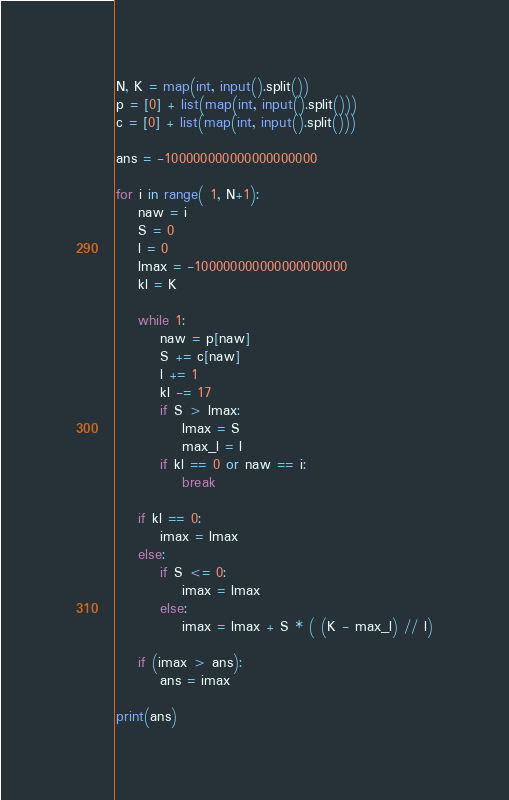Convert code to text. <code><loc_0><loc_0><loc_500><loc_500><_Python_>N, K = map(int, input().split())
p = [0] + list(map(int, input().split()))
c = [0] + list(map(int, input().split()))

ans = -100000000000000000000

for i in range( 1, N+1):
    naw = i
    S = 0
    l = 0
    lmax = -100000000000000000000
    kl = K

    while 1:
        naw = p[naw]
        S += c[naw]
        l += 1
        kl -= 17
        if S > lmax:
            lmax = S
            max_l = l
        if kl == 0 or naw == i:
            break
    
    if kl == 0:
        imax = lmax
    else:
        if S <= 0:
            imax = lmax
        else:
            imax = lmax + S * ( (K - max_l) // l)
    
    if (imax > ans):
        ans = imax

print(ans)</code> 